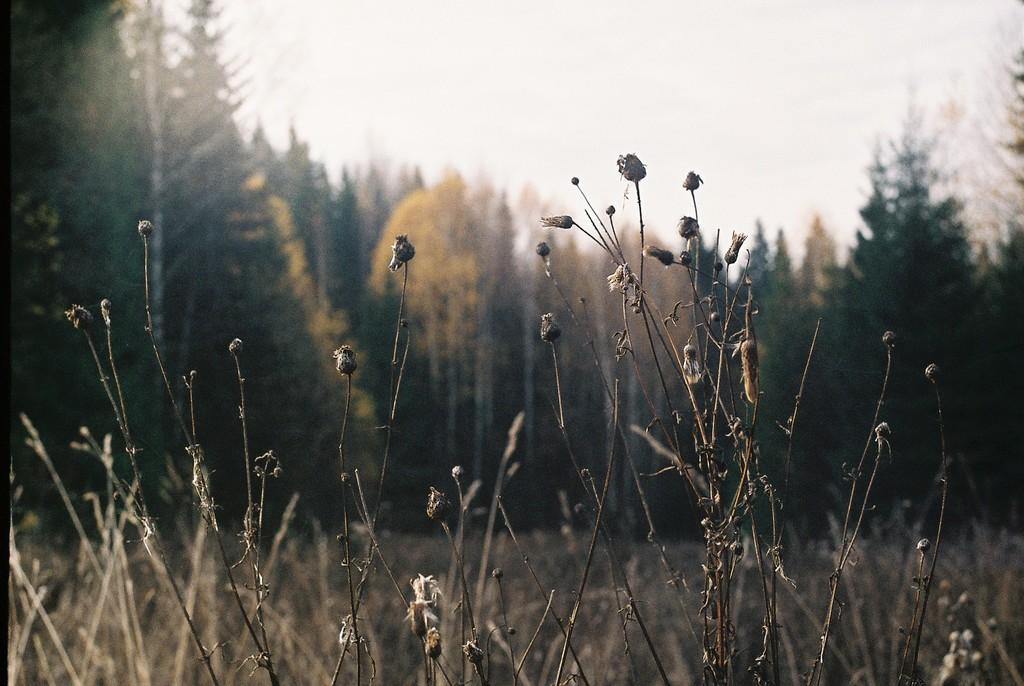What type of plants can be seen in the image? There are dry plants in the image. What specific type of dry plants are present? There are dry flowers in the image. What can be seen in the background of the image? There are trees in the background of the image. What is visible at the top of the image? The sky is visible at the top of the image. How is the background of the image depicted? The image is blurred in the background. What type of lumber is being used to construct the nation in the image? There is no reference to a nation or lumber in the image; it features dry plants, dry flowers, trees, and a blurred background. 